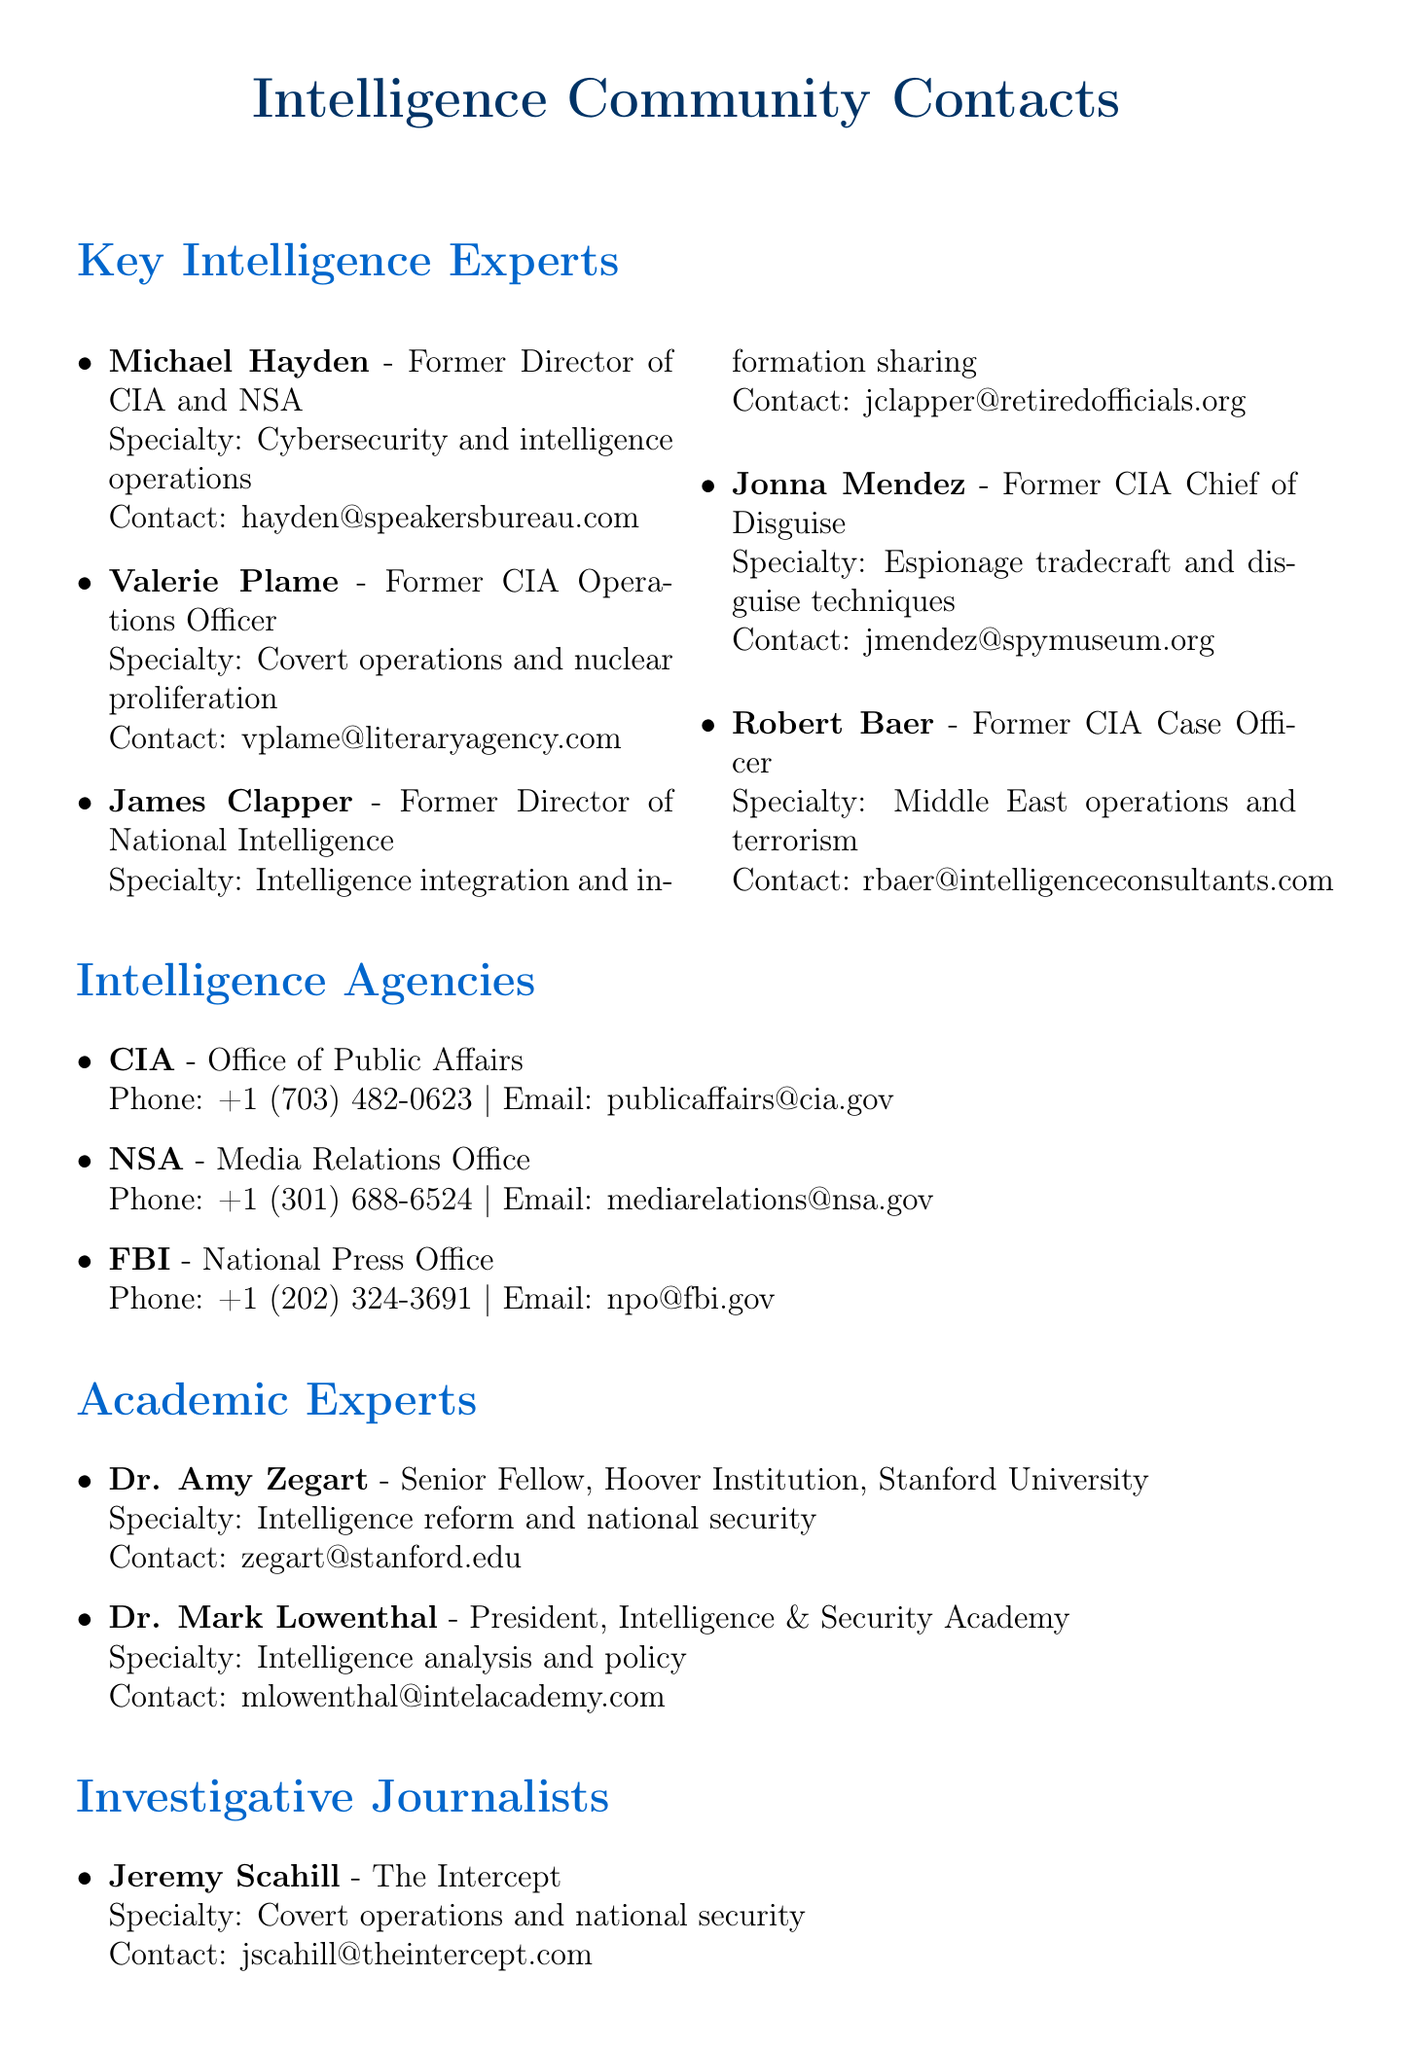What is the specialty of Michael Hayden? The specialty of Michael Hayden is stated as "Cybersecurity and intelligence operations" in the document.
Answer: Cybersecurity and intelligence operations Who should be contacted for National Press Office at FBI? The document indicates that the National Press Office at FBI can be contacted, but does not list a specific individual, instead providing general contact info.
Answer: National Press Office What is Valerie Plame's availability for interviews? The document notes that Valerie Plame is "Available for interviews, book tour ongoing."
Answer: Available for interviews, book tour ongoing Which agency does Dr. Amy Zegart work for? The document states that Dr. Amy Zegart is a Senior Fellow at the Hoover Institution, Stanford University.
Answer: Hoover Institution, Stanford University How many investigative journalists are listed in the document? The document lists two investigative journalists: Jeremy Scahill and Jane Mayer.
Answer: Two What is the contact email for Jonna Mendez? The contact email for Jonna Mendez is listed as "jmendez@spymuseum.org" in the document.
Answer: jmendez@spymuseum.org Which filmmaker specializes in interviews with intelligence officials? The document indicates that Errol Morris specializes in interviews with intelligence officials.
Answer: Errol Morris What is the title of James Clapper? The title of James Clapper is "Former Director of National Intelligence" as mentioned in the document.
Answer: Former Director of National Intelligence How can one contact Alex Gibney? The document states to contact Alex Gibney through his production company, providing a generic contact email.
Answer: Contact through production company 